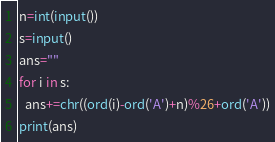<code> <loc_0><loc_0><loc_500><loc_500><_Python_>n=int(input())
s=input()
ans=""
for i in s:
  ans+=chr((ord(i)-ord('A')+n)%26+ord('A'))
print(ans)
</code> 